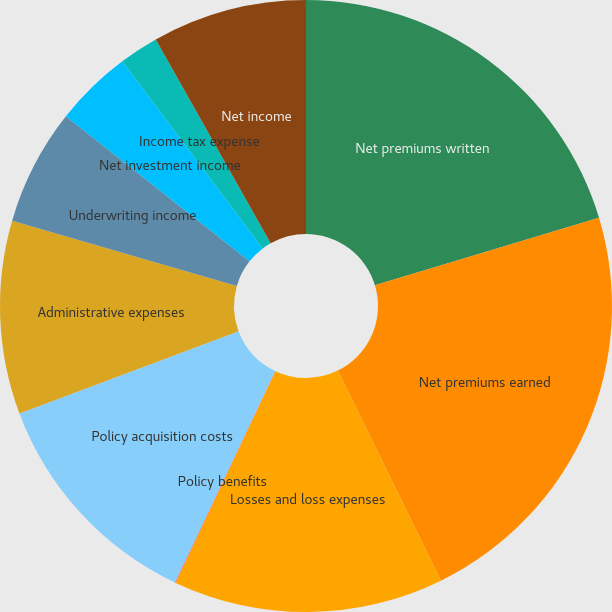Convert chart to OTSL. <chart><loc_0><loc_0><loc_500><loc_500><pie_chart><fcel>Net premiums written<fcel>Net premiums earned<fcel>Losses and loss expenses<fcel>Policy benefits<fcel>Policy acquisition costs<fcel>Administrative expenses<fcel>Underwriting income<fcel>Net investment income<fcel>Income tax expense<fcel>Net income<nl><fcel>20.35%<fcel>22.38%<fcel>14.27%<fcel>0.05%<fcel>12.24%<fcel>10.21%<fcel>6.14%<fcel>4.11%<fcel>2.08%<fcel>8.17%<nl></chart> 